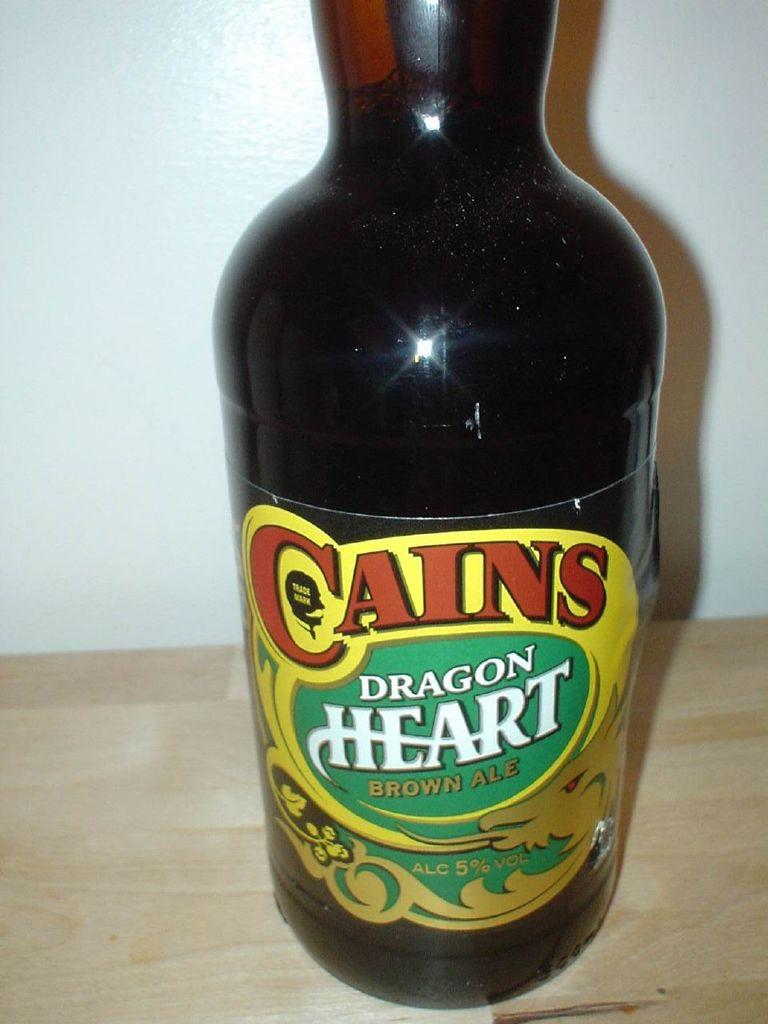<image>
Present a compact description of the photo's key features. Bottle of Cains Dragon heart brown beer that contains five percent alcohol 